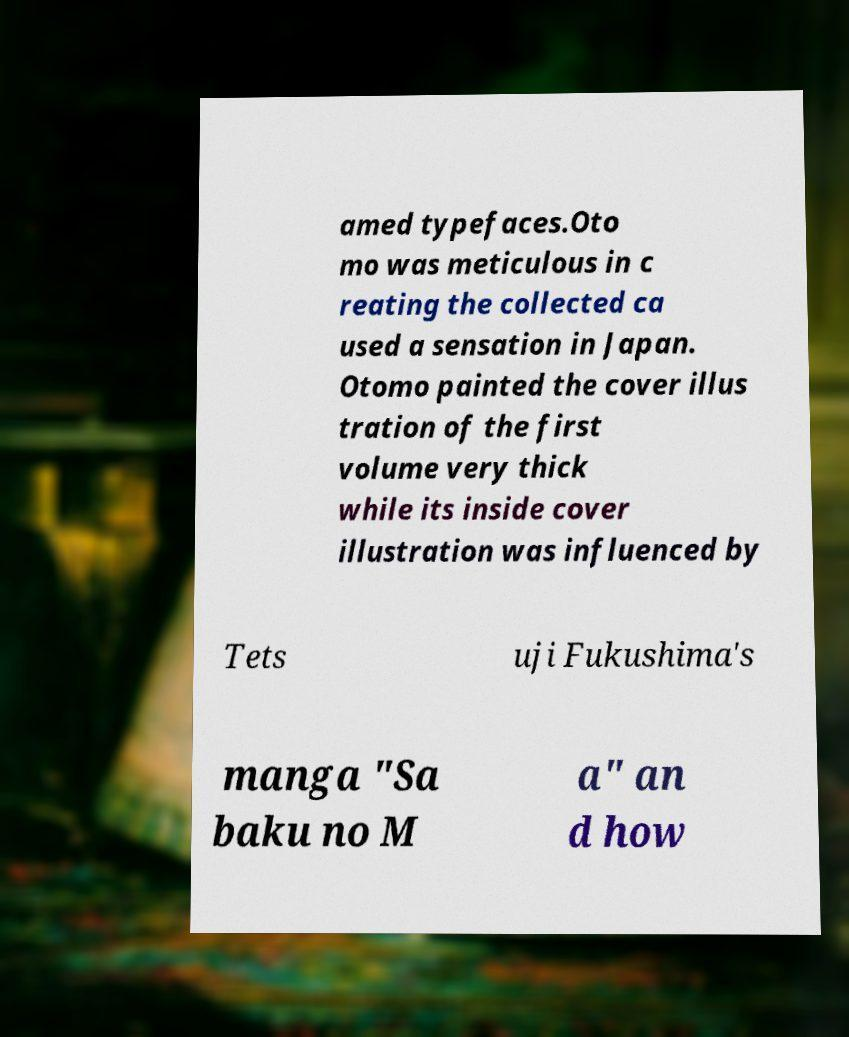I need the written content from this picture converted into text. Can you do that? amed typefaces.Oto mo was meticulous in c reating the collected ca used a sensation in Japan. Otomo painted the cover illus tration of the first volume very thick while its inside cover illustration was influenced by Tets uji Fukushima's manga "Sa baku no M a" an d how 